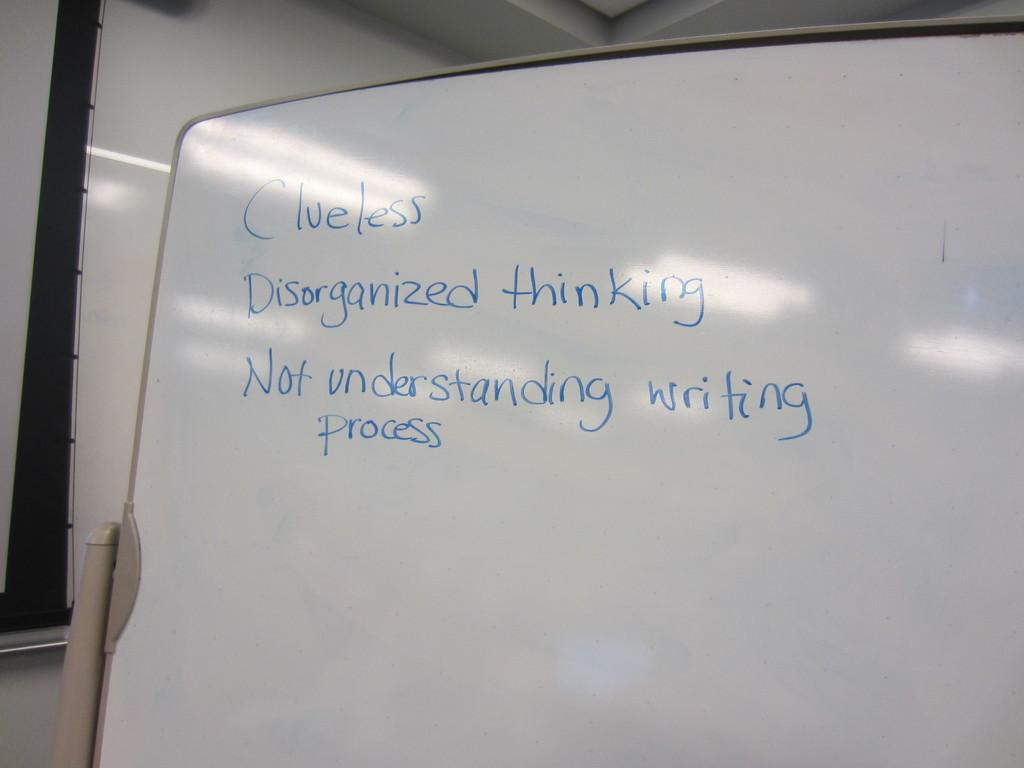Provide a one-sentence caption for the provided image. A white board with blue writing on it and that contains three negative items. 